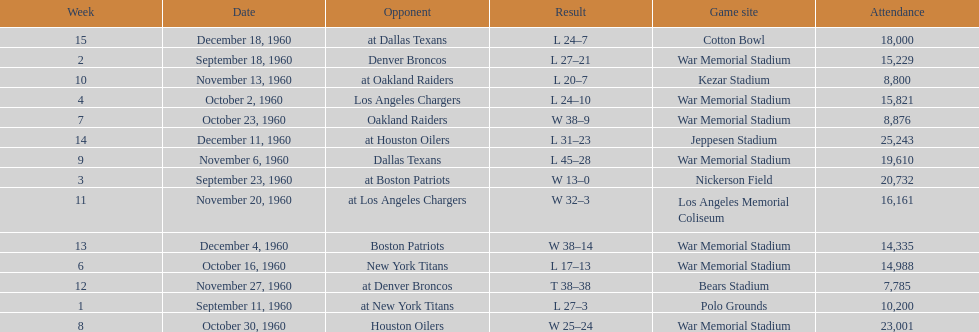Who was the only opponent they played which resulted in a tie game? Denver Broncos. 